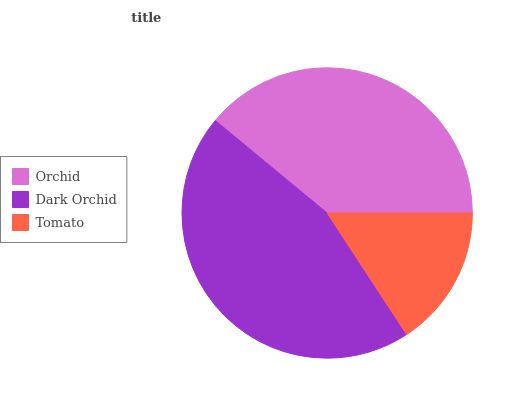Is Tomato the minimum?
Answer yes or no. Yes. Is Dark Orchid the maximum?
Answer yes or no. Yes. Is Dark Orchid the minimum?
Answer yes or no. No. Is Tomato the maximum?
Answer yes or no. No. Is Dark Orchid greater than Tomato?
Answer yes or no. Yes. Is Tomato less than Dark Orchid?
Answer yes or no. Yes. Is Tomato greater than Dark Orchid?
Answer yes or no. No. Is Dark Orchid less than Tomato?
Answer yes or no. No. Is Orchid the high median?
Answer yes or no. Yes. Is Orchid the low median?
Answer yes or no. Yes. Is Tomato the high median?
Answer yes or no. No. Is Tomato the low median?
Answer yes or no. No. 